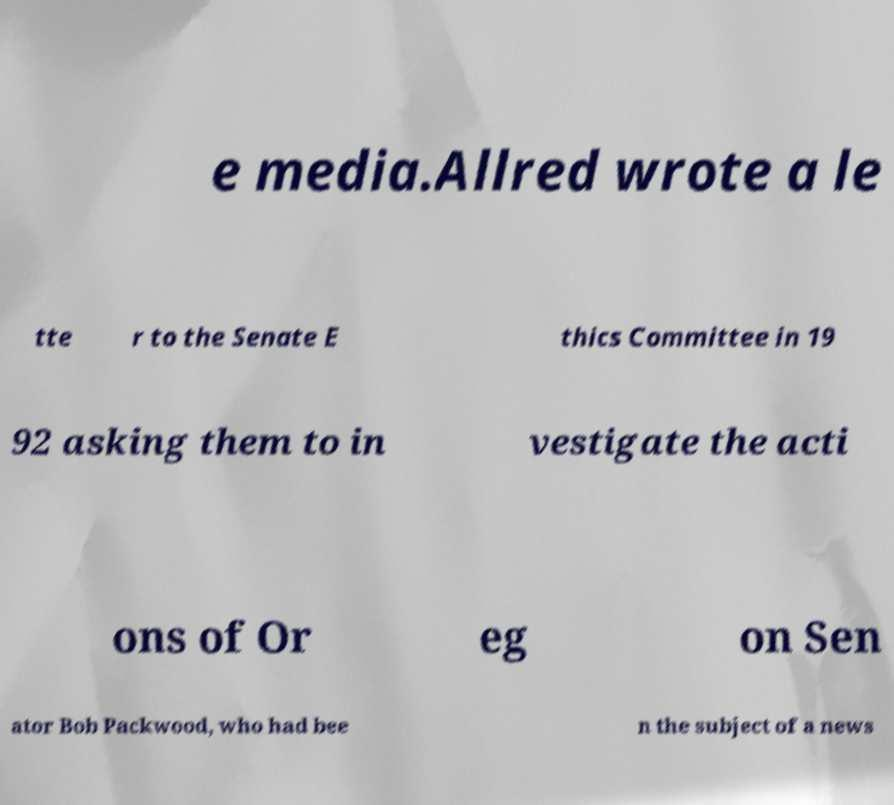For documentation purposes, I need the text within this image transcribed. Could you provide that? e media.Allred wrote a le tte r to the Senate E thics Committee in 19 92 asking them to in vestigate the acti ons of Or eg on Sen ator Bob Packwood, who had bee n the subject of a news 